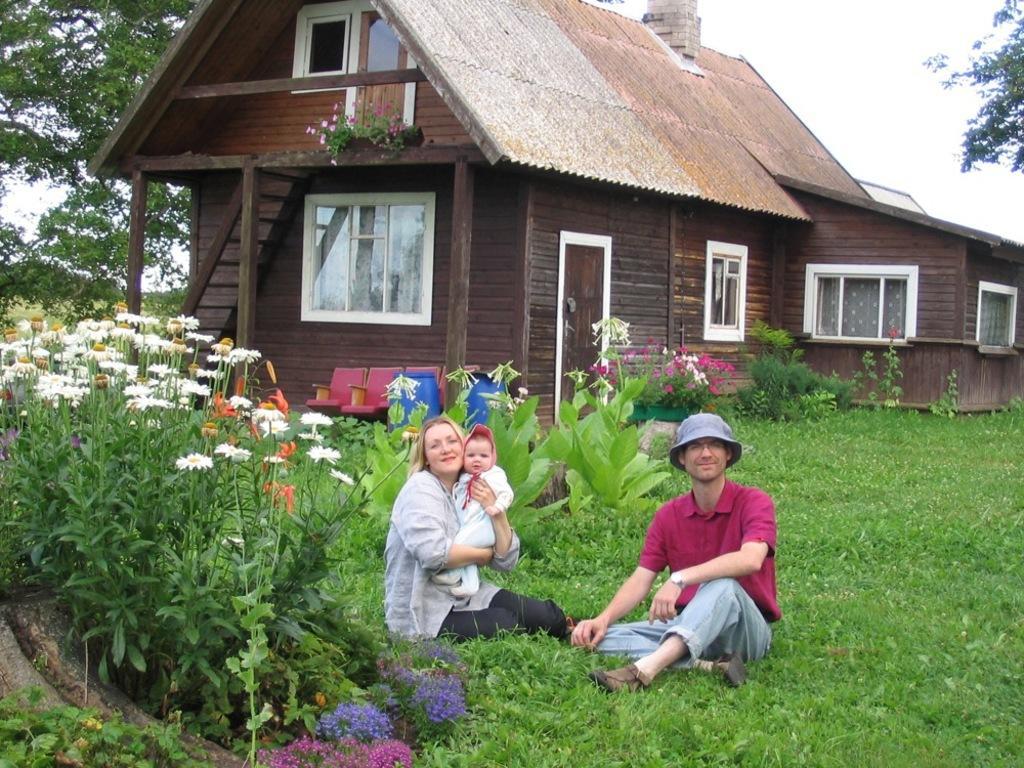Please provide a concise description of this image. In this image we can see person wearing maroon color t-shirt and hat and a woman is carrying a child are sitting on the grass. Here we can see the flower plants, blue color cans, chairs, wooden house, stairs, windows, trees and the sky in the background. 